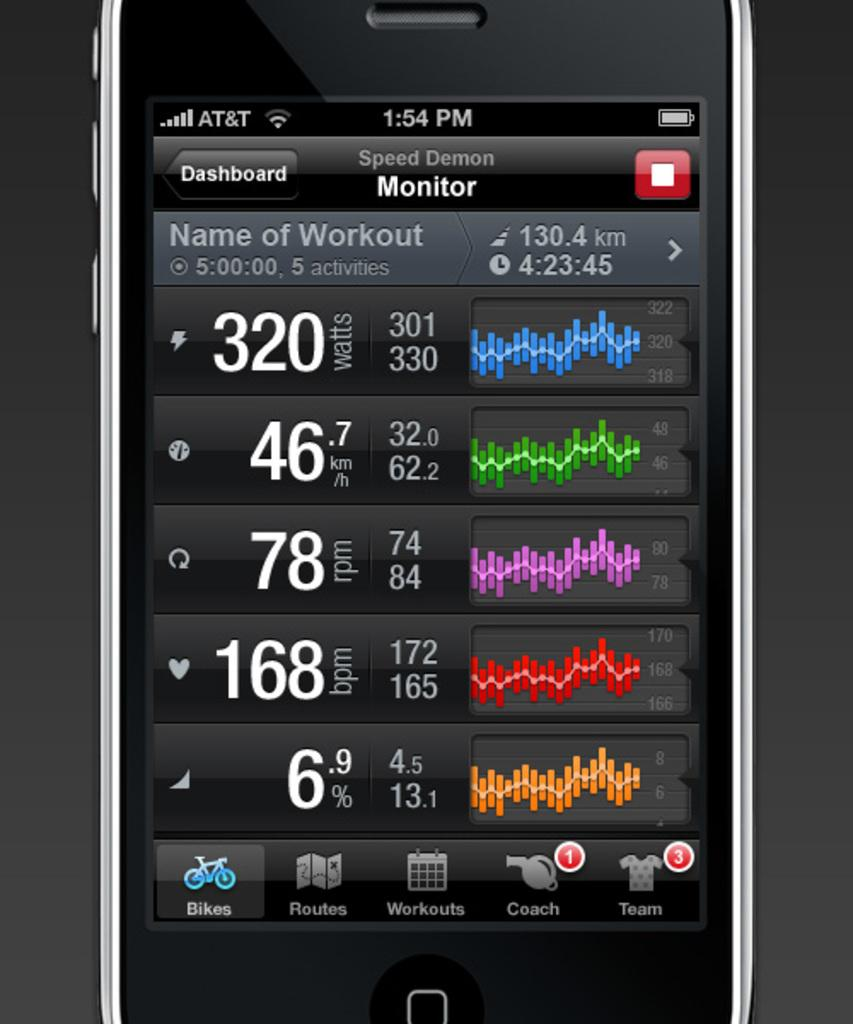Provide a one-sentence caption for the provided image. A phone app monitor named Spped Demon showing the different graphs. 